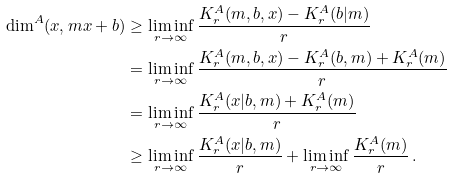<formula> <loc_0><loc_0><loc_500><loc_500>\dim ^ { A } ( x , m x + b ) & \geq \liminf _ { r \to \infty } \frac { K ^ { A } _ { r } ( m , b , x ) - K ^ { A } _ { r } ( b | m ) } { r } \\ & = \liminf _ { r \to \infty } \frac { K ^ { A } _ { r } ( m , b , x ) - K ^ { A } _ { r } ( b , m ) + K ^ { A } _ { r } ( m ) } { r } \\ & = \liminf _ { r \to \infty } \frac { K ^ { A } _ { r } ( x | b , m ) + K ^ { A } _ { r } ( m ) } { r } \\ & \geq \liminf _ { r \to \infty } \frac { K ^ { A } _ { r } ( x | b , m ) } { r } + \liminf _ { r \to \infty } \frac { K ^ { A } _ { r } ( m ) } { r } \, .</formula> 